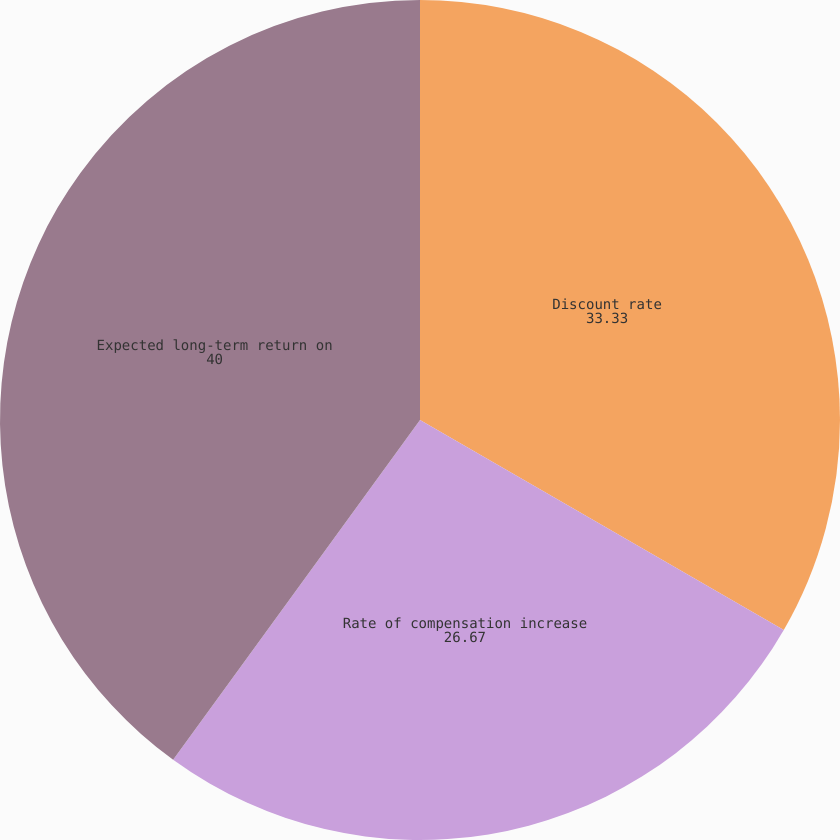<chart> <loc_0><loc_0><loc_500><loc_500><pie_chart><fcel>Discount rate<fcel>Rate of compensation increase<fcel>Expected long-term return on<nl><fcel>33.33%<fcel>26.67%<fcel>40.0%<nl></chart> 